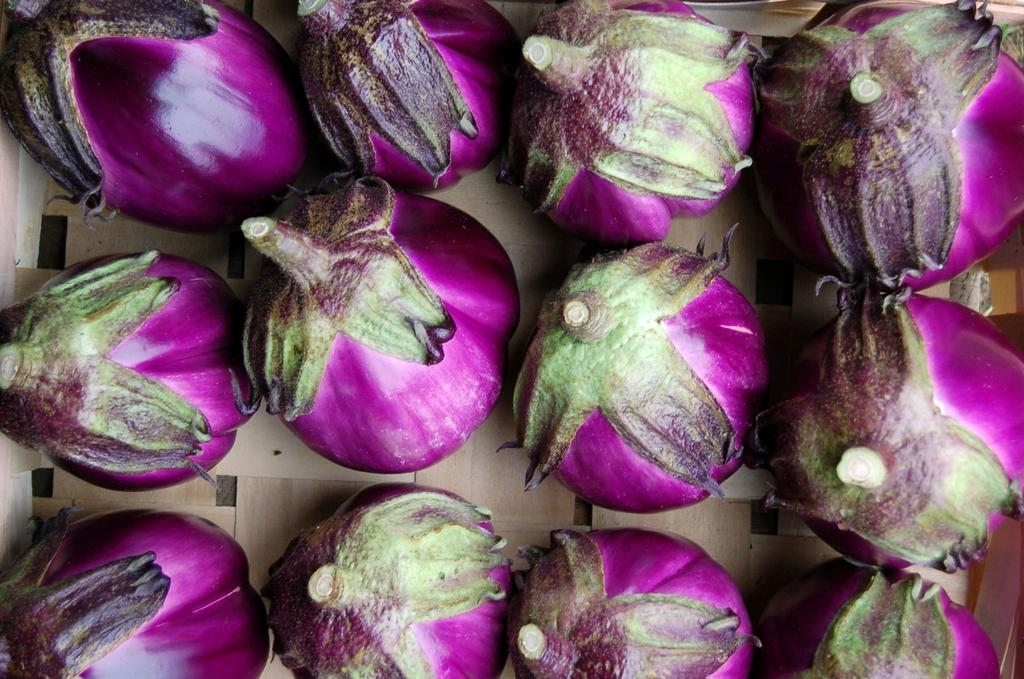What type of food can be seen in the image? There are vegetables in the image. How many giants are holding the vegetables in the image? There are no giants present in the image, as it only features vegetables. What type of glove can be seen in the image? There is no glove present in the image; it only contains vegetables. 